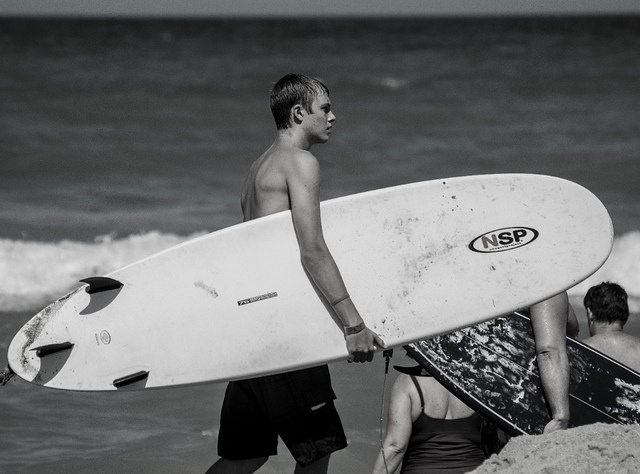Describe the objects in this image and their specific colors. I can see surfboard in gray, lightgray, darkgray, and black tones, people in gray, black, darkgray, and lightgray tones, surfboard in gray, black, darkgray, and lightgray tones, people in gray, black, and darkgray tones, and people in gray, darkgray, and black tones in this image. 